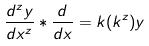Convert formula to latex. <formula><loc_0><loc_0><loc_500><loc_500>\frac { d ^ { z } y } { d x ^ { z } } * \frac { d } { d x } = k ( k ^ { z } ) y</formula> 